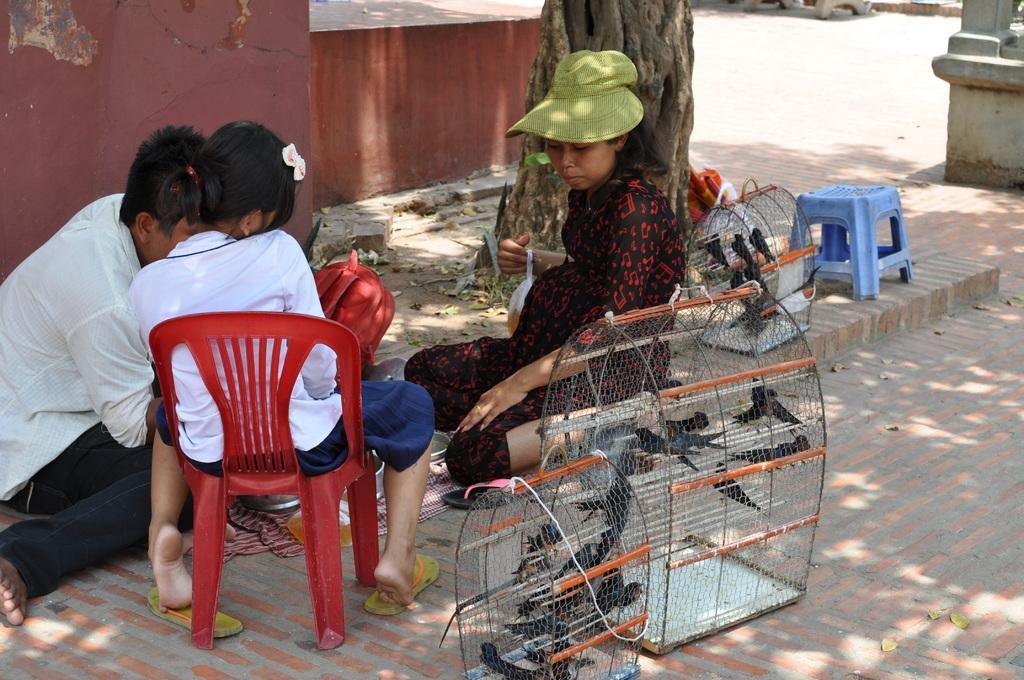In one or two sentences, can you explain what this image depicts? A girl is sitting on the red chair. Beside her a person is sitting. A lady is sitting wearing a green cap. And there is a bag on the floor. There are two cages. Inside cages there are many birds. And there is a tree. In the background there is a red wall. There is a blue color stool on the sidewalk. 